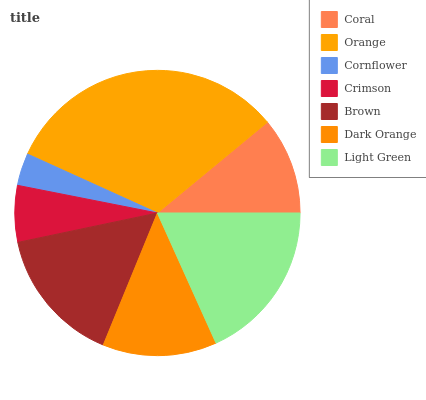Is Cornflower the minimum?
Answer yes or no. Yes. Is Orange the maximum?
Answer yes or no. Yes. Is Orange the minimum?
Answer yes or no. No. Is Cornflower the maximum?
Answer yes or no. No. Is Orange greater than Cornflower?
Answer yes or no. Yes. Is Cornflower less than Orange?
Answer yes or no. Yes. Is Cornflower greater than Orange?
Answer yes or no. No. Is Orange less than Cornflower?
Answer yes or no. No. Is Dark Orange the high median?
Answer yes or no. Yes. Is Dark Orange the low median?
Answer yes or no. Yes. Is Crimson the high median?
Answer yes or no. No. Is Light Green the low median?
Answer yes or no. No. 